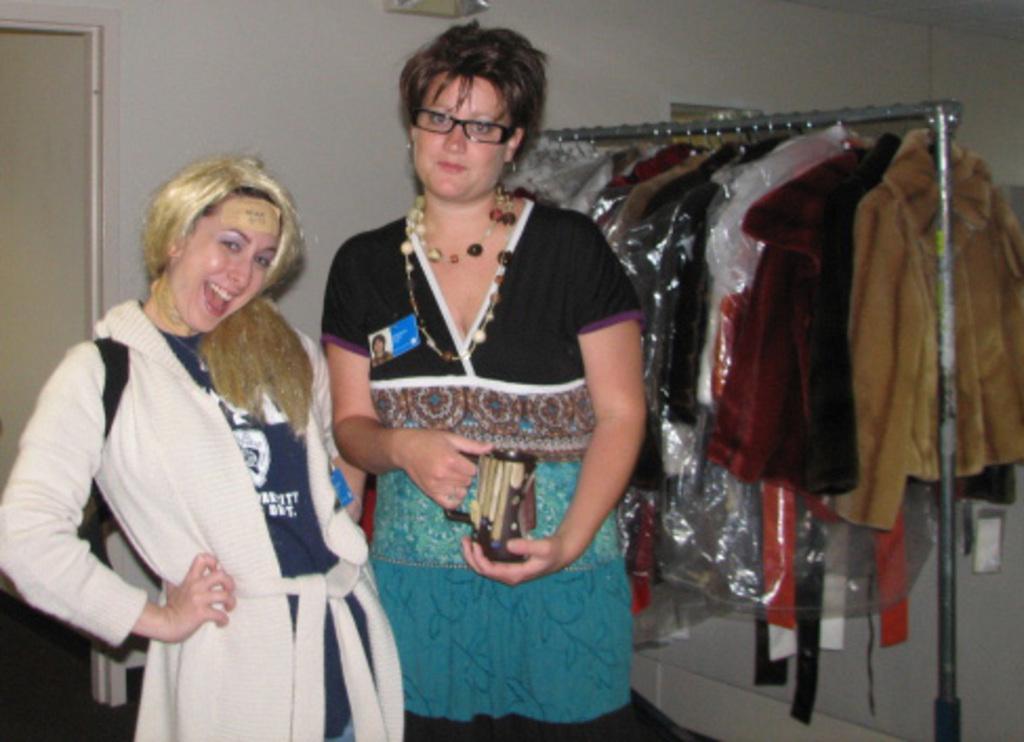Could you give a brief overview of what you see in this image? This picture is clicked inside the room. Here, we see two women are standing. The woman in the white sweater is smiling. Beside her, the woman in the black and blue dress is holding a cup in her hands. Beside them, we see sweaters hanged to the hangers. Behind them, we see a door and a white wall. 